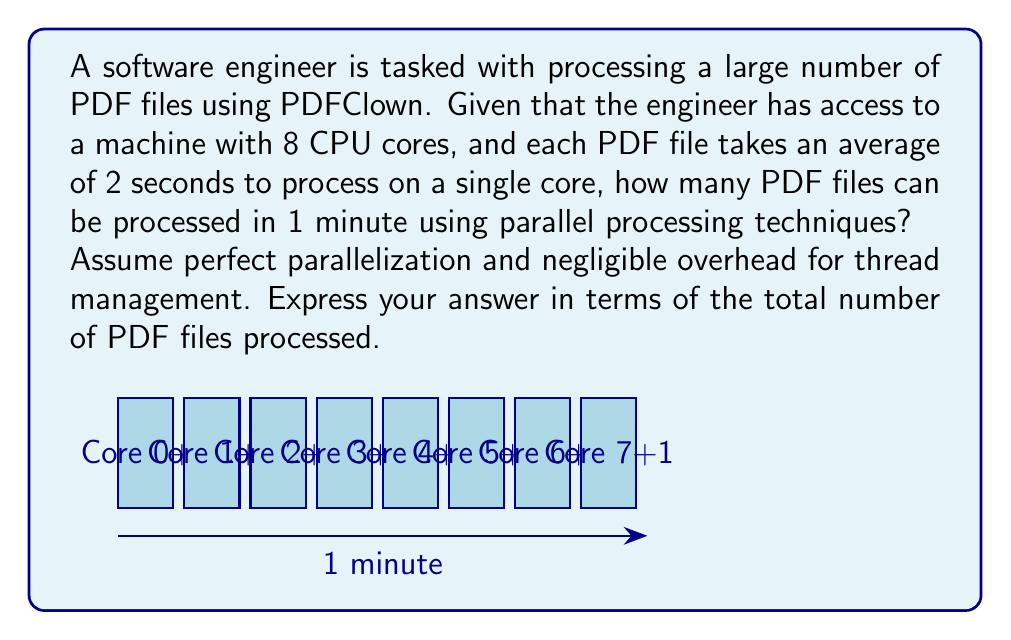Help me with this question. Let's approach this step-by-step:

1) First, let's calculate how many PDF files a single core can process in 1 minute:
   $$\text{Files per core} = \frac{\text{Time available}}{\text{Time per file}} = \frac{60 \text{ seconds}}{2 \text{ seconds/file}} = 30 \text{ files}$$

2) Now, we have 8 cores working in parallel. Assuming perfect parallelization, we can multiply the number of files processed by a single core by the number of cores:
   $$\text{Total files} = \text{Files per core} \times \text{Number of cores}$$
   $$\text{Total files} = 30 \times 8 = 240$$

3) Therefore, in 1 minute, with 8 cores working in parallel, the system can process 240 PDF files.

This solution assumes ideal conditions with perfect parallelization and no overhead for thread management. In real-world scenarios, there might be some overhead and the actual number of files processed could be slightly lower.
Answer: 240 PDF files 